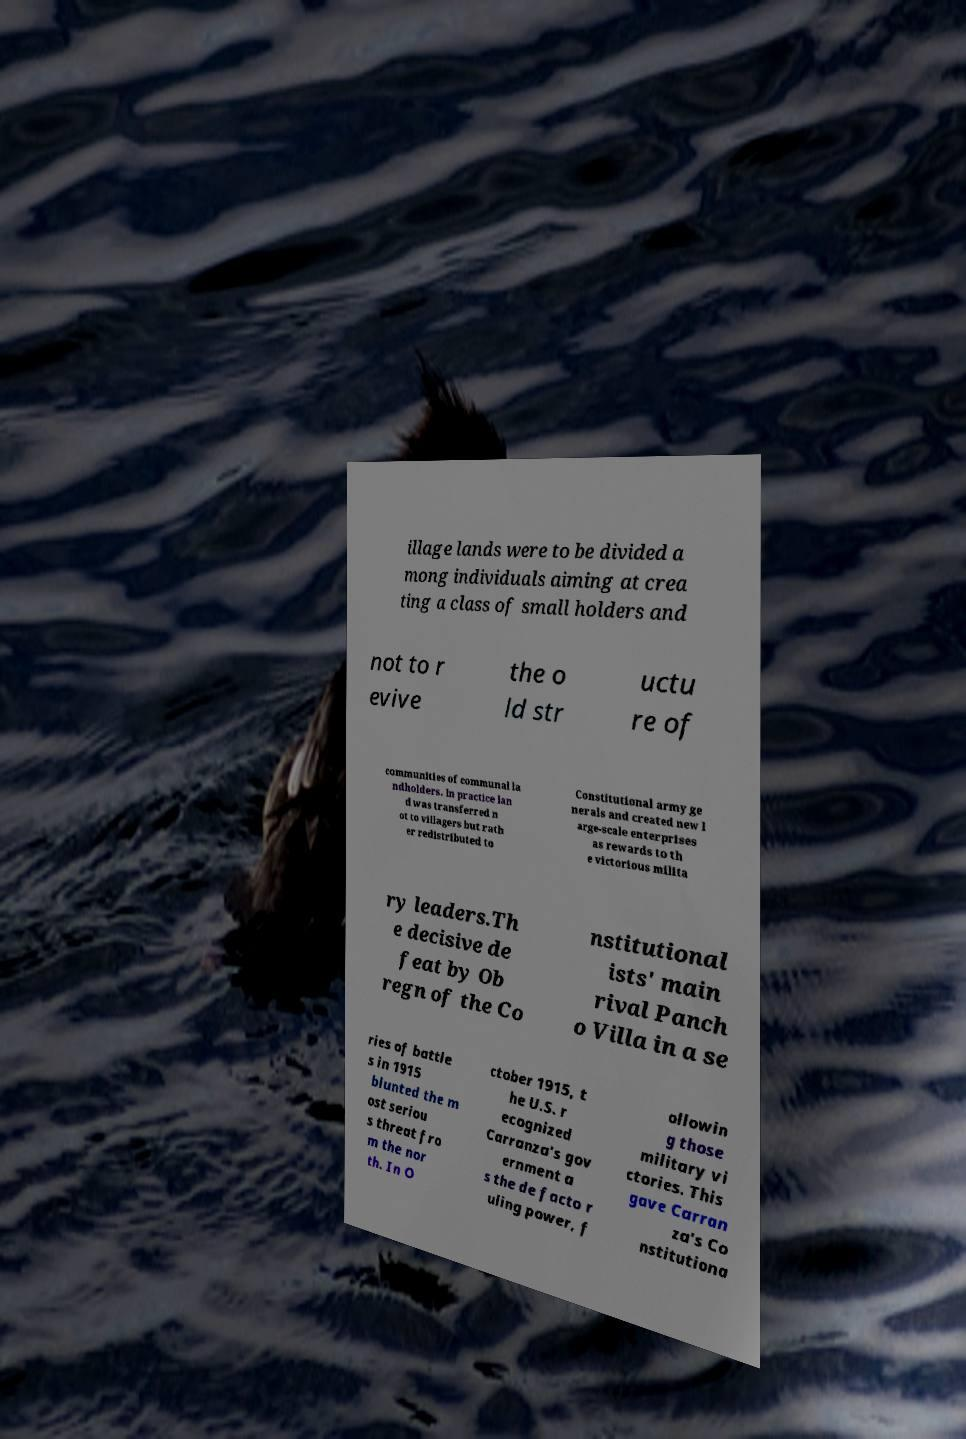There's text embedded in this image that I need extracted. Can you transcribe it verbatim? illage lands were to be divided a mong individuals aiming at crea ting a class of small holders and not to r evive the o ld str uctu re of communities of communal la ndholders. In practice lan d was transferred n ot to villagers but rath er redistributed to Constitutional army ge nerals and created new l arge-scale enterprises as rewards to th e victorious milita ry leaders.Th e decisive de feat by Ob regn of the Co nstitutional ists' main rival Panch o Villa in a se ries of battle s in 1915 blunted the m ost seriou s threat fro m the nor th. In O ctober 1915, t he U.S. r ecognized Carranza's gov ernment a s the de facto r uling power, f ollowin g those military vi ctories. This gave Carran za's Co nstitutiona 